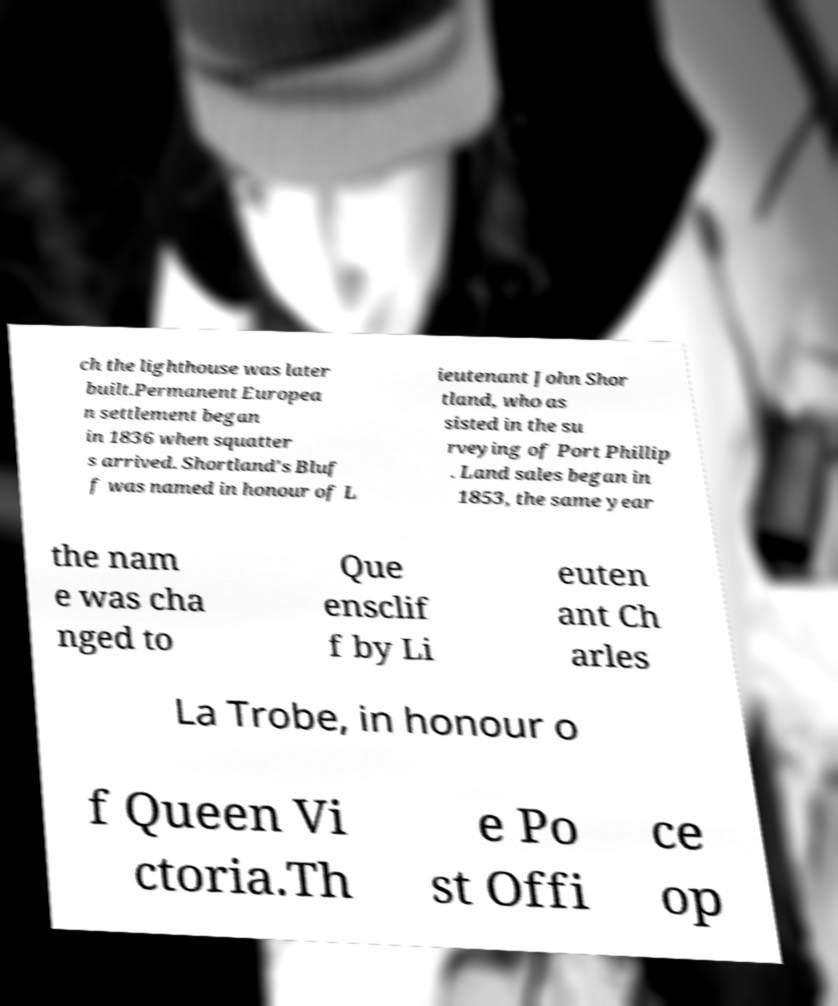There's text embedded in this image that I need extracted. Can you transcribe it verbatim? ch the lighthouse was later built.Permanent Europea n settlement began in 1836 when squatter s arrived. Shortland's Bluf f was named in honour of L ieutenant John Shor tland, who as sisted in the su rveying of Port Phillip . Land sales began in 1853, the same year the nam e was cha nged to Que ensclif f by Li euten ant Ch arles La Trobe, in honour o f Queen Vi ctoria.Th e Po st Offi ce op 